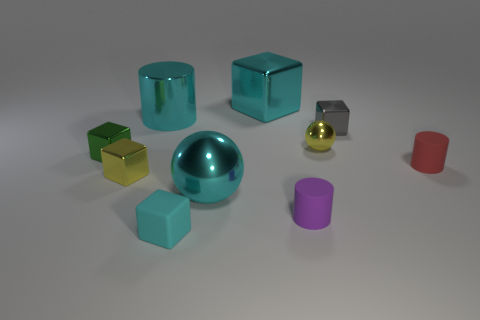Subtract all tiny blocks. How many blocks are left? 1 Subtract all cyan cylinders. How many cylinders are left? 2 Subtract all green balls. How many cyan blocks are left? 2 Subtract all cylinders. How many objects are left? 7 Add 4 tiny green metal objects. How many tiny green metal objects are left? 5 Add 5 purple cylinders. How many purple cylinders exist? 6 Subtract 2 cyan cubes. How many objects are left? 8 Subtract 1 cylinders. How many cylinders are left? 2 Subtract all brown cylinders. Subtract all red balls. How many cylinders are left? 3 Subtract all small gray blocks. Subtract all metallic cylinders. How many objects are left? 8 